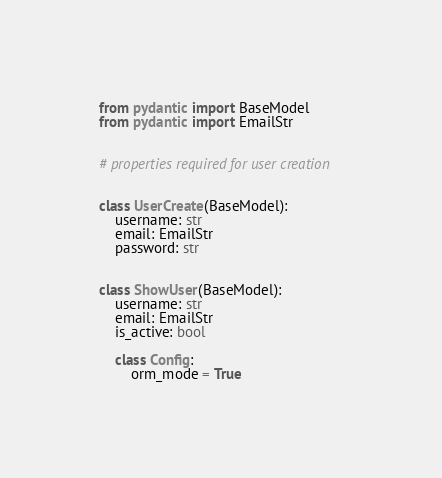<code> <loc_0><loc_0><loc_500><loc_500><_Python_>from pydantic import BaseModel
from pydantic import EmailStr


# properties required for user creation


class UserCreate(BaseModel):
    username: str
    email: EmailStr
    password: str


class ShowUser(BaseModel):
    username: str
    email: EmailStr
    is_active: bool

    class Config:
        orm_mode = True
</code> 